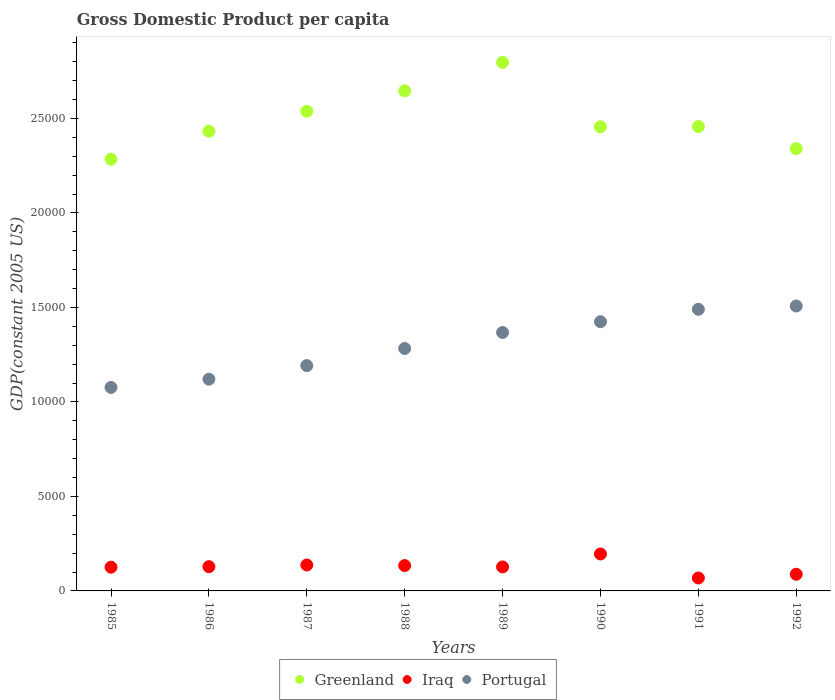How many different coloured dotlines are there?
Keep it short and to the point. 3. What is the GDP per capita in Portugal in 1987?
Offer a very short reply. 1.19e+04. Across all years, what is the maximum GDP per capita in Iraq?
Your response must be concise. 1954.86. Across all years, what is the minimum GDP per capita in Iraq?
Provide a succinct answer. 684.25. In which year was the GDP per capita in Portugal minimum?
Ensure brevity in your answer.  1985. What is the total GDP per capita in Portugal in the graph?
Make the answer very short. 1.05e+05. What is the difference between the GDP per capita in Iraq in 1989 and that in 1992?
Offer a terse response. 388.01. What is the difference between the GDP per capita in Portugal in 1989 and the GDP per capita in Greenland in 1990?
Your response must be concise. -1.09e+04. What is the average GDP per capita in Iraq per year?
Ensure brevity in your answer.  1255.23. In the year 1987, what is the difference between the GDP per capita in Iraq and GDP per capita in Portugal?
Ensure brevity in your answer.  -1.06e+04. What is the ratio of the GDP per capita in Iraq in 1985 to that in 1992?
Make the answer very short. 1.42. What is the difference between the highest and the second highest GDP per capita in Greenland?
Your response must be concise. 1506.96. What is the difference between the highest and the lowest GDP per capita in Portugal?
Your answer should be compact. 4308.08. In how many years, is the GDP per capita in Greenland greater than the average GDP per capita in Greenland taken over all years?
Provide a succinct answer. 3. Does the GDP per capita in Portugal monotonically increase over the years?
Your answer should be compact. Yes. Is the GDP per capita in Greenland strictly greater than the GDP per capita in Iraq over the years?
Give a very brief answer. Yes. Is the GDP per capita in Iraq strictly less than the GDP per capita in Greenland over the years?
Offer a very short reply. Yes. How many dotlines are there?
Your answer should be very brief. 3. Are the values on the major ticks of Y-axis written in scientific E-notation?
Your answer should be very brief. No. Does the graph contain any zero values?
Offer a terse response. No. What is the title of the graph?
Keep it short and to the point. Gross Domestic Product per capita. What is the label or title of the Y-axis?
Your answer should be compact. GDP(constant 2005 US). What is the GDP(constant 2005 US) of Greenland in 1985?
Provide a short and direct response. 2.28e+04. What is the GDP(constant 2005 US) of Iraq in 1985?
Offer a very short reply. 1254.49. What is the GDP(constant 2005 US) in Portugal in 1985?
Ensure brevity in your answer.  1.08e+04. What is the GDP(constant 2005 US) in Greenland in 1986?
Make the answer very short. 2.43e+04. What is the GDP(constant 2005 US) in Iraq in 1986?
Keep it short and to the point. 1283.02. What is the GDP(constant 2005 US) in Portugal in 1986?
Your answer should be compact. 1.12e+04. What is the GDP(constant 2005 US) of Greenland in 1987?
Keep it short and to the point. 2.54e+04. What is the GDP(constant 2005 US) of Iraq in 1987?
Your response must be concise. 1371.78. What is the GDP(constant 2005 US) of Portugal in 1987?
Your response must be concise. 1.19e+04. What is the GDP(constant 2005 US) of Greenland in 1988?
Provide a short and direct response. 2.65e+04. What is the GDP(constant 2005 US) of Iraq in 1988?
Offer a very short reply. 1341.55. What is the GDP(constant 2005 US) of Portugal in 1988?
Provide a succinct answer. 1.28e+04. What is the GDP(constant 2005 US) in Greenland in 1989?
Give a very brief answer. 2.80e+04. What is the GDP(constant 2005 US) of Iraq in 1989?
Make the answer very short. 1269.95. What is the GDP(constant 2005 US) of Portugal in 1989?
Offer a very short reply. 1.37e+04. What is the GDP(constant 2005 US) of Greenland in 1990?
Your answer should be compact. 2.46e+04. What is the GDP(constant 2005 US) in Iraq in 1990?
Give a very brief answer. 1954.86. What is the GDP(constant 2005 US) in Portugal in 1990?
Offer a terse response. 1.42e+04. What is the GDP(constant 2005 US) in Greenland in 1991?
Your answer should be very brief. 2.46e+04. What is the GDP(constant 2005 US) of Iraq in 1991?
Make the answer very short. 684.25. What is the GDP(constant 2005 US) in Portugal in 1991?
Keep it short and to the point. 1.49e+04. What is the GDP(constant 2005 US) of Greenland in 1992?
Provide a short and direct response. 2.34e+04. What is the GDP(constant 2005 US) of Iraq in 1992?
Make the answer very short. 881.94. What is the GDP(constant 2005 US) of Portugal in 1992?
Ensure brevity in your answer.  1.51e+04. Across all years, what is the maximum GDP(constant 2005 US) in Greenland?
Keep it short and to the point. 2.80e+04. Across all years, what is the maximum GDP(constant 2005 US) of Iraq?
Give a very brief answer. 1954.86. Across all years, what is the maximum GDP(constant 2005 US) of Portugal?
Provide a succinct answer. 1.51e+04. Across all years, what is the minimum GDP(constant 2005 US) of Greenland?
Your answer should be compact. 2.28e+04. Across all years, what is the minimum GDP(constant 2005 US) of Iraq?
Offer a terse response. 684.25. Across all years, what is the minimum GDP(constant 2005 US) of Portugal?
Your response must be concise. 1.08e+04. What is the total GDP(constant 2005 US) in Greenland in the graph?
Offer a very short reply. 2.00e+05. What is the total GDP(constant 2005 US) of Iraq in the graph?
Ensure brevity in your answer.  1.00e+04. What is the total GDP(constant 2005 US) of Portugal in the graph?
Your answer should be compact. 1.05e+05. What is the difference between the GDP(constant 2005 US) in Greenland in 1985 and that in 1986?
Make the answer very short. -1483.84. What is the difference between the GDP(constant 2005 US) in Iraq in 1985 and that in 1986?
Your answer should be very brief. -28.53. What is the difference between the GDP(constant 2005 US) of Portugal in 1985 and that in 1986?
Keep it short and to the point. -435.71. What is the difference between the GDP(constant 2005 US) in Greenland in 1985 and that in 1987?
Offer a very short reply. -2540.85. What is the difference between the GDP(constant 2005 US) in Iraq in 1985 and that in 1987?
Your answer should be compact. -117.29. What is the difference between the GDP(constant 2005 US) of Portugal in 1985 and that in 1987?
Provide a succinct answer. -1153.88. What is the difference between the GDP(constant 2005 US) in Greenland in 1985 and that in 1988?
Keep it short and to the point. -3620.71. What is the difference between the GDP(constant 2005 US) in Iraq in 1985 and that in 1988?
Provide a succinct answer. -87.06. What is the difference between the GDP(constant 2005 US) of Portugal in 1985 and that in 1988?
Make the answer very short. -2060.05. What is the difference between the GDP(constant 2005 US) of Greenland in 1985 and that in 1989?
Provide a short and direct response. -5127.67. What is the difference between the GDP(constant 2005 US) in Iraq in 1985 and that in 1989?
Provide a succinct answer. -15.45. What is the difference between the GDP(constant 2005 US) in Portugal in 1985 and that in 1989?
Provide a short and direct response. -2906.2. What is the difference between the GDP(constant 2005 US) in Greenland in 1985 and that in 1990?
Keep it short and to the point. -1716.81. What is the difference between the GDP(constant 2005 US) in Iraq in 1985 and that in 1990?
Your response must be concise. -700.37. What is the difference between the GDP(constant 2005 US) in Portugal in 1985 and that in 1990?
Offer a very short reply. -3477.42. What is the difference between the GDP(constant 2005 US) in Greenland in 1985 and that in 1991?
Make the answer very short. -1733.15. What is the difference between the GDP(constant 2005 US) of Iraq in 1985 and that in 1991?
Offer a terse response. 570.24. What is the difference between the GDP(constant 2005 US) in Portugal in 1985 and that in 1991?
Ensure brevity in your answer.  -4134. What is the difference between the GDP(constant 2005 US) of Greenland in 1985 and that in 1992?
Offer a very short reply. -561.39. What is the difference between the GDP(constant 2005 US) in Iraq in 1985 and that in 1992?
Make the answer very short. 372.55. What is the difference between the GDP(constant 2005 US) in Portugal in 1985 and that in 1992?
Provide a succinct answer. -4308.08. What is the difference between the GDP(constant 2005 US) in Greenland in 1986 and that in 1987?
Make the answer very short. -1057.01. What is the difference between the GDP(constant 2005 US) of Iraq in 1986 and that in 1987?
Offer a terse response. -88.76. What is the difference between the GDP(constant 2005 US) in Portugal in 1986 and that in 1987?
Your response must be concise. -718.17. What is the difference between the GDP(constant 2005 US) of Greenland in 1986 and that in 1988?
Keep it short and to the point. -2136.87. What is the difference between the GDP(constant 2005 US) of Iraq in 1986 and that in 1988?
Give a very brief answer. -58.53. What is the difference between the GDP(constant 2005 US) of Portugal in 1986 and that in 1988?
Make the answer very short. -1624.35. What is the difference between the GDP(constant 2005 US) in Greenland in 1986 and that in 1989?
Offer a very short reply. -3643.83. What is the difference between the GDP(constant 2005 US) of Iraq in 1986 and that in 1989?
Give a very brief answer. 13.07. What is the difference between the GDP(constant 2005 US) in Portugal in 1986 and that in 1989?
Ensure brevity in your answer.  -2470.5. What is the difference between the GDP(constant 2005 US) in Greenland in 1986 and that in 1990?
Make the answer very short. -232.97. What is the difference between the GDP(constant 2005 US) of Iraq in 1986 and that in 1990?
Offer a very short reply. -671.84. What is the difference between the GDP(constant 2005 US) in Portugal in 1986 and that in 1990?
Ensure brevity in your answer.  -3041.72. What is the difference between the GDP(constant 2005 US) of Greenland in 1986 and that in 1991?
Provide a succinct answer. -249.3. What is the difference between the GDP(constant 2005 US) of Iraq in 1986 and that in 1991?
Your answer should be compact. 598.77. What is the difference between the GDP(constant 2005 US) of Portugal in 1986 and that in 1991?
Offer a very short reply. -3698.3. What is the difference between the GDP(constant 2005 US) in Greenland in 1986 and that in 1992?
Ensure brevity in your answer.  922.46. What is the difference between the GDP(constant 2005 US) of Iraq in 1986 and that in 1992?
Offer a terse response. 401.08. What is the difference between the GDP(constant 2005 US) of Portugal in 1986 and that in 1992?
Offer a terse response. -3872.37. What is the difference between the GDP(constant 2005 US) in Greenland in 1987 and that in 1988?
Provide a short and direct response. -1079.85. What is the difference between the GDP(constant 2005 US) of Iraq in 1987 and that in 1988?
Keep it short and to the point. 30.23. What is the difference between the GDP(constant 2005 US) in Portugal in 1987 and that in 1988?
Offer a very short reply. -906.18. What is the difference between the GDP(constant 2005 US) of Greenland in 1987 and that in 1989?
Ensure brevity in your answer.  -2586.82. What is the difference between the GDP(constant 2005 US) of Iraq in 1987 and that in 1989?
Your response must be concise. 101.83. What is the difference between the GDP(constant 2005 US) in Portugal in 1987 and that in 1989?
Your answer should be compact. -1752.33. What is the difference between the GDP(constant 2005 US) of Greenland in 1987 and that in 1990?
Provide a short and direct response. 824.04. What is the difference between the GDP(constant 2005 US) of Iraq in 1987 and that in 1990?
Keep it short and to the point. -583.08. What is the difference between the GDP(constant 2005 US) in Portugal in 1987 and that in 1990?
Your response must be concise. -2323.55. What is the difference between the GDP(constant 2005 US) of Greenland in 1987 and that in 1991?
Your answer should be very brief. 807.71. What is the difference between the GDP(constant 2005 US) of Iraq in 1987 and that in 1991?
Offer a very short reply. 687.53. What is the difference between the GDP(constant 2005 US) of Portugal in 1987 and that in 1991?
Your response must be concise. -2980.13. What is the difference between the GDP(constant 2005 US) of Greenland in 1987 and that in 1992?
Give a very brief answer. 1979.47. What is the difference between the GDP(constant 2005 US) of Iraq in 1987 and that in 1992?
Give a very brief answer. 489.84. What is the difference between the GDP(constant 2005 US) of Portugal in 1987 and that in 1992?
Provide a succinct answer. -3154.2. What is the difference between the GDP(constant 2005 US) in Greenland in 1988 and that in 1989?
Provide a succinct answer. -1506.96. What is the difference between the GDP(constant 2005 US) in Iraq in 1988 and that in 1989?
Your answer should be compact. 71.6. What is the difference between the GDP(constant 2005 US) in Portugal in 1988 and that in 1989?
Offer a very short reply. -846.15. What is the difference between the GDP(constant 2005 US) in Greenland in 1988 and that in 1990?
Give a very brief answer. 1903.89. What is the difference between the GDP(constant 2005 US) in Iraq in 1988 and that in 1990?
Make the answer very short. -613.31. What is the difference between the GDP(constant 2005 US) in Portugal in 1988 and that in 1990?
Offer a terse response. -1417.37. What is the difference between the GDP(constant 2005 US) in Greenland in 1988 and that in 1991?
Provide a succinct answer. 1887.56. What is the difference between the GDP(constant 2005 US) of Iraq in 1988 and that in 1991?
Provide a succinct answer. 657.3. What is the difference between the GDP(constant 2005 US) in Portugal in 1988 and that in 1991?
Ensure brevity in your answer.  -2073.95. What is the difference between the GDP(constant 2005 US) in Greenland in 1988 and that in 1992?
Give a very brief answer. 3059.32. What is the difference between the GDP(constant 2005 US) in Iraq in 1988 and that in 1992?
Keep it short and to the point. 459.61. What is the difference between the GDP(constant 2005 US) of Portugal in 1988 and that in 1992?
Ensure brevity in your answer.  -2248.02. What is the difference between the GDP(constant 2005 US) in Greenland in 1989 and that in 1990?
Keep it short and to the point. 3410.86. What is the difference between the GDP(constant 2005 US) of Iraq in 1989 and that in 1990?
Your answer should be compact. -684.92. What is the difference between the GDP(constant 2005 US) in Portugal in 1989 and that in 1990?
Your answer should be very brief. -571.22. What is the difference between the GDP(constant 2005 US) in Greenland in 1989 and that in 1991?
Make the answer very short. 3394.52. What is the difference between the GDP(constant 2005 US) in Iraq in 1989 and that in 1991?
Offer a very short reply. 585.69. What is the difference between the GDP(constant 2005 US) of Portugal in 1989 and that in 1991?
Offer a terse response. -1227.8. What is the difference between the GDP(constant 2005 US) in Greenland in 1989 and that in 1992?
Keep it short and to the point. 4566.28. What is the difference between the GDP(constant 2005 US) of Iraq in 1989 and that in 1992?
Your response must be concise. 388.01. What is the difference between the GDP(constant 2005 US) of Portugal in 1989 and that in 1992?
Provide a short and direct response. -1401.87. What is the difference between the GDP(constant 2005 US) in Greenland in 1990 and that in 1991?
Give a very brief answer. -16.33. What is the difference between the GDP(constant 2005 US) in Iraq in 1990 and that in 1991?
Make the answer very short. 1270.61. What is the difference between the GDP(constant 2005 US) of Portugal in 1990 and that in 1991?
Your answer should be very brief. -656.58. What is the difference between the GDP(constant 2005 US) in Greenland in 1990 and that in 1992?
Your answer should be very brief. 1155.43. What is the difference between the GDP(constant 2005 US) of Iraq in 1990 and that in 1992?
Keep it short and to the point. 1072.92. What is the difference between the GDP(constant 2005 US) of Portugal in 1990 and that in 1992?
Give a very brief answer. -830.65. What is the difference between the GDP(constant 2005 US) of Greenland in 1991 and that in 1992?
Make the answer very short. 1171.76. What is the difference between the GDP(constant 2005 US) of Iraq in 1991 and that in 1992?
Your answer should be compact. -197.68. What is the difference between the GDP(constant 2005 US) in Portugal in 1991 and that in 1992?
Offer a terse response. -174.07. What is the difference between the GDP(constant 2005 US) of Greenland in 1985 and the GDP(constant 2005 US) of Iraq in 1986?
Your answer should be compact. 2.16e+04. What is the difference between the GDP(constant 2005 US) in Greenland in 1985 and the GDP(constant 2005 US) in Portugal in 1986?
Offer a terse response. 1.16e+04. What is the difference between the GDP(constant 2005 US) in Iraq in 1985 and the GDP(constant 2005 US) in Portugal in 1986?
Make the answer very short. -9949.29. What is the difference between the GDP(constant 2005 US) in Greenland in 1985 and the GDP(constant 2005 US) in Iraq in 1987?
Provide a succinct answer. 2.15e+04. What is the difference between the GDP(constant 2005 US) in Greenland in 1985 and the GDP(constant 2005 US) in Portugal in 1987?
Ensure brevity in your answer.  1.09e+04. What is the difference between the GDP(constant 2005 US) of Iraq in 1985 and the GDP(constant 2005 US) of Portugal in 1987?
Offer a very short reply. -1.07e+04. What is the difference between the GDP(constant 2005 US) of Greenland in 1985 and the GDP(constant 2005 US) of Iraq in 1988?
Provide a succinct answer. 2.15e+04. What is the difference between the GDP(constant 2005 US) of Greenland in 1985 and the GDP(constant 2005 US) of Portugal in 1988?
Offer a terse response. 1.00e+04. What is the difference between the GDP(constant 2005 US) in Iraq in 1985 and the GDP(constant 2005 US) in Portugal in 1988?
Ensure brevity in your answer.  -1.16e+04. What is the difference between the GDP(constant 2005 US) in Greenland in 1985 and the GDP(constant 2005 US) in Iraq in 1989?
Keep it short and to the point. 2.16e+04. What is the difference between the GDP(constant 2005 US) of Greenland in 1985 and the GDP(constant 2005 US) of Portugal in 1989?
Provide a short and direct response. 9165.37. What is the difference between the GDP(constant 2005 US) in Iraq in 1985 and the GDP(constant 2005 US) in Portugal in 1989?
Provide a short and direct response. -1.24e+04. What is the difference between the GDP(constant 2005 US) in Greenland in 1985 and the GDP(constant 2005 US) in Iraq in 1990?
Your answer should be very brief. 2.09e+04. What is the difference between the GDP(constant 2005 US) in Greenland in 1985 and the GDP(constant 2005 US) in Portugal in 1990?
Keep it short and to the point. 8594.15. What is the difference between the GDP(constant 2005 US) of Iraq in 1985 and the GDP(constant 2005 US) of Portugal in 1990?
Your answer should be compact. -1.30e+04. What is the difference between the GDP(constant 2005 US) in Greenland in 1985 and the GDP(constant 2005 US) in Iraq in 1991?
Make the answer very short. 2.22e+04. What is the difference between the GDP(constant 2005 US) in Greenland in 1985 and the GDP(constant 2005 US) in Portugal in 1991?
Your response must be concise. 7937.57. What is the difference between the GDP(constant 2005 US) of Iraq in 1985 and the GDP(constant 2005 US) of Portugal in 1991?
Keep it short and to the point. -1.36e+04. What is the difference between the GDP(constant 2005 US) of Greenland in 1985 and the GDP(constant 2005 US) of Iraq in 1992?
Offer a very short reply. 2.20e+04. What is the difference between the GDP(constant 2005 US) of Greenland in 1985 and the GDP(constant 2005 US) of Portugal in 1992?
Make the answer very short. 7763.5. What is the difference between the GDP(constant 2005 US) of Iraq in 1985 and the GDP(constant 2005 US) of Portugal in 1992?
Make the answer very short. -1.38e+04. What is the difference between the GDP(constant 2005 US) of Greenland in 1986 and the GDP(constant 2005 US) of Iraq in 1987?
Your response must be concise. 2.30e+04. What is the difference between the GDP(constant 2005 US) in Greenland in 1986 and the GDP(constant 2005 US) in Portugal in 1987?
Offer a very short reply. 1.24e+04. What is the difference between the GDP(constant 2005 US) of Iraq in 1986 and the GDP(constant 2005 US) of Portugal in 1987?
Provide a short and direct response. -1.06e+04. What is the difference between the GDP(constant 2005 US) of Greenland in 1986 and the GDP(constant 2005 US) of Iraq in 1988?
Provide a short and direct response. 2.30e+04. What is the difference between the GDP(constant 2005 US) of Greenland in 1986 and the GDP(constant 2005 US) of Portugal in 1988?
Offer a terse response. 1.15e+04. What is the difference between the GDP(constant 2005 US) of Iraq in 1986 and the GDP(constant 2005 US) of Portugal in 1988?
Your response must be concise. -1.15e+04. What is the difference between the GDP(constant 2005 US) in Greenland in 1986 and the GDP(constant 2005 US) in Iraq in 1989?
Give a very brief answer. 2.31e+04. What is the difference between the GDP(constant 2005 US) of Greenland in 1986 and the GDP(constant 2005 US) of Portugal in 1989?
Your answer should be compact. 1.06e+04. What is the difference between the GDP(constant 2005 US) of Iraq in 1986 and the GDP(constant 2005 US) of Portugal in 1989?
Your answer should be very brief. -1.24e+04. What is the difference between the GDP(constant 2005 US) of Greenland in 1986 and the GDP(constant 2005 US) of Iraq in 1990?
Offer a terse response. 2.24e+04. What is the difference between the GDP(constant 2005 US) of Greenland in 1986 and the GDP(constant 2005 US) of Portugal in 1990?
Give a very brief answer. 1.01e+04. What is the difference between the GDP(constant 2005 US) of Iraq in 1986 and the GDP(constant 2005 US) of Portugal in 1990?
Make the answer very short. -1.30e+04. What is the difference between the GDP(constant 2005 US) in Greenland in 1986 and the GDP(constant 2005 US) in Iraq in 1991?
Make the answer very short. 2.36e+04. What is the difference between the GDP(constant 2005 US) of Greenland in 1986 and the GDP(constant 2005 US) of Portugal in 1991?
Make the answer very short. 9421.42. What is the difference between the GDP(constant 2005 US) of Iraq in 1986 and the GDP(constant 2005 US) of Portugal in 1991?
Your response must be concise. -1.36e+04. What is the difference between the GDP(constant 2005 US) in Greenland in 1986 and the GDP(constant 2005 US) in Iraq in 1992?
Offer a very short reply. 2.34e+04. What is the difference between the GDP(constant 2005 US) of Greenland in 1986 and the GDP(constant 2005 US) of Portugal in 1992?
Offer a terse response. 9247.34. What is the difference between the GDP(constant 2005 US) in Iraq in 1986 and the GDP(constant 2005 US) in Portugal in 1992?
Provide a succinct answer. -1.38e+04. What is the difference between the GDP(constant 2005 US) in Greenland in 1987 and the GDP(constant 2005 US) in Iraq in 1988?
Ensure brevity in your answer.  2.40e+04. What is the difference between the GDP(constant 2005 US) of Greenland in 1987 and the GDP(constant 2005 US) of Portugal in 1988?
Ensure brevity in your answer.  1.26e+04. What is the difference between the GDP(constant 2005 US) in Iraq in 1987 and the GDP(constant 2005 US) in Portugal in 1988?
Make the answer very short. -1.15e+04. What is the difference between the GDP(constant 2005 US) of Greenland in 1987 and the GDP(constant 2005 US) of Iraq in 1989?
Give a very brief answer. 2.41e+04. What is the difference between the GDP(constant 2005 US) in Greenland in 1987 and the GDP(constant 2005 US) in Portugal in 1989?
Your answer should be compact. 1.17e+04. What is the difference between the GDP(constant 2005 US) of Iraq in 1987 and the GDP(constant 2005 US) of Portugal in 1989?
Ensure brevity in your answer.  -1.23e+04. What is the difference between the GDP(constant 2005 US) of Greenland in 1987 and the GDP(constant 2005 US) of Iraq in 1990?
Your answer should be very brief. 2.34e+04. What is the difference between the GDP(constant 2005 US) in Greenland in 1987 and the GDP(constant 2005 US) in Portugal in 1990?
Keep it short and to the point. 1.11e+04. What is the difference between the GDP(constant 2005 US) of Iraq in 1987 and the GDP(constant 2005 US) of Portugal in 1990?
Your answer should be compact. -1.29e+04. What is the difference between the GDP(constant 2005 US) in Greenland in 1987 and the GDP(constant 2005 US) in Iraq in 1991?
Offer a very short reply. 2.47e+04. What is the difference between the GDP(constant 2005 US) in Greenland in 1987 and the GDP(constant 2005 US) in Portugal in 1991?
Provide a succinct answer. 1.05e+04. What is the difference between the GDP(constant 2005 US) of Iraq in 1987 and the GDP(constant 2005 US) of Portugal in 1991?
Your answer should be compact. -1.35e+04. What is the difference between the GDP(constant 2005 US) in Greenland in 1987 and the GDP(constant 2005 US) in Iraq in 1992?
Your answer should be compact. 2.45e+04. What is the difference between the GDP(constant 2005 US) in Greenland in 1987 and the GDP(constant 2005 US) in Portugal in 1992?
Your answer should be very brief. 1.03e+04. What is the difference between the GDP(constant 2005 US) of Iraq in 1987 and the GDP(constant 2005 US) of Portugal in 1992?
Make the answer very short. -1.37e+04. What is the difference between the GDP(constant 2005 US) of Greenland in 1988 and the GDP(constant 2005 US) of Iraq in 1989?
Provide a succinct answer. 2.52e+04. What is the difference between the GDP(constant 2005 US) of Greenland in 1988 and the GDP(constant 2005 US) of Portugal in 1989?
Your response must be concise. 1.28e+04. What is the difference between the GDP(constant 2005 US) of Iraq in 1988 and the GDP(constant 2005 US) of Portugal in 1989?
Your answer should be very brief. -1.23e+04. What is the difference between the GDP(constant 2005 US) of Greenland in 1988 and the GDP(constant 2005 US) of Iraq in 1990?
Offer a very short reply. 2.45e+04. What is the difference between the GDP(constant 2005 US) in Greenland in 1988 and the GDP(constant 2005 US) in Portugal in 1990?
Your answer should be compact. 1.22e+04. What is the difference between the GDP(constant 2005 US) in Iraq in 1988 and the GDP(constant 2005 US) in Portugal in 1990?
Your answer should be very brief. -1.29e+04. What is the difference between the GDP(constant 2005 US) of Greenland in 1988 and the GDP(constant 2005 US) of Iraq in 1991?
Offer a very short reply. 2.58e+04. What is the difference between the GDP(constant 2005 US) in Greenland in 1988 and the GDP(constant 2005 US) in Portugal in 1991?
Provide a short and direct response. 1.16e+04. What is the difference between the GDP(constant 2005 US) of Iraq in 1988 and the GDP(constant 2005 US) of Portugal in 1991?
Offer a very short reply. -1.36e+04. What is the difference between the GDP(constant 2005 US) of Greenland in 1988 and the GDP(constant 2005 US) of Iraq in 1992?
Ensure brevity in your answer.  2.56e+04. What is the difference between the GDP(constant 2005 US) of Greenland in 1988 and the GDP(constant 2005 US) of Portugal in 1992?
Ensure brevity in your answer.  1.14e+04. What is the difference between the GDP(constant 2005 US) of Iraq in 1988 and the GDP(constant 2005 US) of Portugal in 1992?
Your answer should be very brief. -1.37e+04. What is the difference between the GDP(constant 2005 US) of Greenland in 1989 and the GDP(constant 2005 US) of Iraq in 1990?
Your answer should be compact. 2.60e+04. What is the difference between the GDP(constant 2005 US) in Greenland in 1989 and the GDP(constant 2005 US) in Portugal in 1990?
Your response must be concise. 1.37e+04. What is the difference between the GDP(constant 2005 US) in Iraq in 1989 and the GDP(constant 2005 US) in Portugal in 1990?
Provide a succinct answer. -1.30e+04. What is the difference between the GDP(constant 2005 US) of Greenland in 1989 and the GDP(constant 2005 US) of Iraq in 1991?
Provide a succinct answer. 2.73e+04. What is the difference between the GDP(constant 2005 US) of Greenland in 1989 and the GDP(constant 2005 US) of Portugal in 1991?
Keep it short and to the point. 1.31e+04. What is the difference between the GDP(constant 2005 US) in Iraq in 1989 and the GDP(constant 2005 US) in Portugal in 1991?
Your answer should be compact. -1.36e+04. What is the difference between the GDP(constant 2005 US) of Greenland in 1989 and the GDP(constant 2005 US) of Iraq in 1992?
Your response must be concise. 2.71e+04. What is the difference between the GDP(constant 2005 US) of Greenland in 1989 and the GDP(constant 2005 US) of Portugal in 1992?
Offer a very short reply. 1.29e+04. What is the difference between the GDP(constant 2005 US) of Iraq in 1989 and the GDP(constant 2005 US) of Portugal in 1992?
Your answer should be compact. -1.38e+04. What is the difference between the GDP(constant 2005 US) of Greenland in 1990 and the GDP(constant 2005 US) of Iraq in 1991?
Provide a short and direct response. 2.39e+04. What is the difference between the GDP(constant 2005 US) of Greenland in 1990 and the GDP(constant 2005 US) of Portugal in 1991?
Provide a succinct answer. 9654.39. What is the difference between the GDP(constant 2005 US) in Iraq in 1990 and the GDP(constant 2005 US) in Portugal in 1991?
Provide a succinct answer. -1.29e+04. What is the difference between the GDP(constant 2005 US) in Greenland in 1990 and the GDP(constant 2005 US) in Iraq in 1992?
Provide a short and direct response. 2.37e+04. What is the difference between the GDP(constant 2005 US) of Greenland in 1990 and the GDP(constant 2005 US) of Portugal in 1992?
Provide a short and direct response. 9480.32. What is the difference between the GDP(constant 2005 US) in Iraq in 1990 and the GDP(constant 2005 US) in Portugal in 1992?
Your answer should be compact. -1.31e+04. What is the difference between the GDP(constant 2005 US) of Greenland in 1991 and the GDP(constant 2005 US) of Iraq in 1992?
Provide a short and direct response. 2.37e+04. What is the difference between the GDP(constant 2005 US) in Greenland in 1991 and the GDP(constant 2005 US) in Portugal in 1992?
Provide a short and direct response. 9496.65. What is the difference between the GDP(constant 2005 US) in Iraq in 1991 and the GDP(constant 2005 US) in Portugal in 1992?
Provide a short and direct response. -1.44e+04. What is the average GDP(constant 2005 US) in Greenland per year?
Provide a short and direct response. 2.49e+04. What is the average GDP(constant 2005 US) in Iraq per year?
Give a very brief answer. 1255.23. What is the average GDP(constant 2005 US) in Portugal per year?
Your answer should be compact. 1.31e+04. In the year 1985, what is the difference between the GDP(constant 2005 US) in Greenland and GDP(constant 2005 US) in Iraq?
Provide a succinct answer. 2.16e+04. In the year 1985, what is the difference between the GDP(constant 2005 US) in Greenland and GDP(constant 2005 US) in Portugal?
Provide a short and direct response. 1.21e+04. In the year 1985, what is the difference between the GDP(constant 2005 US) of Iraq and GDP(constant 2005 US) of Portugal?
Offer a terse response. -9513.59. In the year 1986, what is the difference between the GDP(constant 2005 US) in Greenland and GDP(constant 2005 US) in Iraq?
Ensure brevity in your answer.  2.30e+04. In the year 1986, what is the difference between the GDP(constant 2005 US) in Greenland and GDP(constant 2005 US) in Portugal?
Keep it short and to the point. 1.31e+04. In the year 1986, what is the difference between the GDP(constant 2005 US) in Iraq and GDP(constant 2005 US) in Portugal?
Make the answer very short. -9920.76. In the year 1987, what is the difference between the GDP(constant 2005 US) of Greenland and GDP(constant 2005 US) of Iraq?
Provide a short and direct response. 2.40e+04. In the year 1987, what is the difference between the GDP(constant 2005 US) in Greenland and GDP(constant 2005 US) in Portugal?
Provide a short and direct response. 1.35e+04. In the year 1987, what is the difference between the GDP(constant 2005 US) of Iraq and GDP(constant 2005 US) of Portugal?
Your answer should be very brief. -1.06e+04. In the year 1988, what is the difference between the GDP(constant 2005 US) in Greenland and GDP(constant 2005 US) in Iraq?
Your response must be concise. 2.51e+04. In the year 1988, what is the difference between the GDP(constant 2005 US) of Greenland and GDP(constant 2005 US) of Portugal?
Give a very brief answer. 1.36e+04. In the year 1988, what is the difference between the GDP(constant 2005 US) of Iraq and GDP(constant 2005 US) of Portugal?
Keep it short and to the point. -1.15e+04. In the year 1989, what is the difference between the GDP(constant 2005 US) in Greenland and GDP(constant 2005 US) in Iraq?
Ensure brevity in your answer.  2.67e+04. In the year 1989, what is the difference between the GDP(constant 2005 US) of Greenland and GDP(constant 2005 US) of Portugal?
Provide a short and direct response. 1.43e+04. In the year 1989, what is the difference between the GDP(constant 2005 US) of Iraq and GDP(constant 2005 US) of Portugal?
Keep it short and to the point. -1.24e+04. In the year 1990, what is the difference between the GDP(constant 2005 US) of Greenland and GDP(constant 2005 US) of Iraq?
Give a very brief answer. 2.26e+04. In the year 1990, what is the difference between the GDP(constant 2005 US) of Greenland and GDP(constant 2005 US) of Portugal?
Your response must be concise. 1.03e+04. In the year 1990, what is the difference between the GDP(constant 2005 US) in Iraq and GDP(constant 2005 US) in Portugal?
Your answer should be very brief. -1.23e+04. In the year 1991, what is the difference between the GDP(constant 2005 US) in Greenland and GDP(constant 2005 US) in Iraq?
Your answer should be very brief. 2.39e+04. In the year 1991, what is the difference between the GDP(constant 2005 US) in Greenland and GDP(constant 2005 US) in Portugal?
Make the answer very short. 9670.72. In the year 1991, what is the difference between the GDP(constant 2005 US) of Iraq and GDP(constant 2005 US) of Portugal?
Ensure brevity in your answer.  -1.42e+04. In the year 1992, what is the difference between the GDP(constant 2005 US) in Greenland and GDP(constant 2005 US) in Iraq?
Give a very brief answer. 2.25e+04. In the year 1992, what is the difference between the GDP(constant 2005 US) in Greenland and GDP(constant 2005 US) in Portugal?
Make the answer very short. 8324.89. In the year 1992, what is the difference between the GDP(constant 2005 US) in Iraq and GDP(constant 2005 US) in Portugal?
Offer a very short reply. -1.42e+04. What is the ratio of the GDP(constant 2005 US) of Greenland in 1985 to that in 1986?
Give a very brief answer. 0.94. What is the ratio of the GDP(constant 2005 US) of Iraq in 1985 to that in 1986?
Offer a terse response. 0.98. What is the ratio of the GDP(constant 2005 US) of Portugal in 1985 to that in 1986?
Give a very brief answer. 0.96. What is the ratio of the GDP(constant 2005 US) in Greenland in 1985 to that in 1987?
Give a very brief answer. 0.9. What is the ratio of the GDP(constant 2005 US) in Iraq in 1985 to that in 1987?
Keep it short and to the point. 0.91. What is the ratio of the GDP(constant 2005 US) of Portugal in 1985 to that in 1987?
Your answer should be compact. 0.9. What is the ratio of the GDP(constant 2005 US) of Greenland in 1985 to that in 1988?
Offer a terse response. 0.86. What is the ratio of the GDP(constant 2005 US) of Iraq in 1985 to that in 1988?
Ensure brevity in your answer.  0.94. What is the ratio of the GDP(constant 2005 US) of Portugal in 1985 to that in 1988?
Your answer should be compact. 0.84. What is the ratio of the GDP(constant 2005 US) of Greenland in 1985 to that in 1989?
Offer a terse response. 0.82. What is the ratio of the GDP(constant 2005 US) of Iraq in 1985 to that in 1989?
Your answer should be compact. 0.99. What is the ratio of the GDP(constant 2005 US) of Portugal in 1985 to that in 1989?
Offer a terse response. 0.79. What is the ratio of the GDP(constant 2005 US) in Greenland in 1985 to that in 1990?
Give a very brief answer. 0.93. What is the ratio of the GDP(constant 2005 US) of Iraq in 1985 to that in 1990?
Give a very brief answer. 0.64. What is the ratio of the GDP(constant 2005 US) in Portugal in 1985 to that in 1990?
Your response must be concise. 0.76. What is the ratio of the GDP(constant 2005 US) in Greenland in 1985 to that in 1991?
Offer a very short reply. 0.93. What is the ratio of the GDP(constant 2005 US) in Iraq in 1985 to that in 1991?
Make the answer very short. 1.83. What is the ratio of the GDP(constant 2005 US) in Portugal in 1985 to that in 1991?
Provide a succinct answer. 0.72. What is the ratio of the GDP(constant 2005 US) in Iraq in 1985 to that in 1992?
Offer a terse response. 1.42. What is the ratio of the GDP(constant 2005 US) of Portugal in 1985 to that in 1992?
Offer a very short reply. 0.71. What is the ratio of the GDP(constant 2005 US) of Greenland in 1986 to that in 1987?
Ensure brevity in your answer.  0.96. What is the ratio of the GDP(constant 2005 US) in Iraq in 1986 to that in 1987?
Make the answer very short. 0.94. What is the ratio of the GDP(constant 2005 US) of Portugal in 1986 to that in 1987?
Provide a succinct answer. 0.94. What is the ratio of the GDP(constant 2005 US) of Greenland in 1986 to that in 1988?
Your answer should be compact. 0.92. What is the ratio of the GDP(constant 2005 US) in Iraq in 1986 to that in 1988?
Make the answer very short. 0.96. What is the ratio of the GDP(constant 2005 US) in Portugal in 1986 to that in 1988?
Your response must be concise. 0.87. What is the ratio of the GDP(constant 2005 US) in Greenland in 1986 to that in 1989?
Provide a succinct answer. 0.87. What is the ratio of the GDP(constant 2005 US) in Iraq in 1986 to that in 1989?
Provide a succinct answer. 1.01. What is the ratio of the GDP(constant 2005 US) of Portugal in 1986 to that in 1989?
Make the answer very short. 0.82. What is the ratio of the GDP(constant 2005 US) in Iraq in 1986 to that in 1990?
Offer a terse response. 0.66. What is the ratio of the GDP(constant 2005 US) of Portugal in 1986 to that in 1990?
Offer a terse response. 0.79. What is the ratio of the GDP(constant 2005 US) in Iraq in 1986 to that in 1991?
Offer a very short reply. 1.88. What is the ratio of the GDP(constant 2005 US) in Portugal in 1986 to that in 1991?
Your answer should be compact. 0.75. What is the ratio of the GDP(constant 2005 US) in Greenland in 1986 to that in 1992?
Offer a very short reply. 1.04. What is the ratio of the GDP(constant 2005 US) of Iraq in 1986 to that in 1992?
Provide a succinct answer. 1.45. What is the ratio of the GDP(constant 2005 US) in Portugal in 1986 to that in 1992?
Provide a short and direct response. 0.74. What is the ratio of the GDP(constant 2005 US) in Greenland in 1987 to that in 1988?
Provide a succinct answer. 0.96. What is the ratio of the GDP(constant 2005 US) in Iraq in 1987 to that in 1988?
Give a very brief answer. 1.02. What is the ratio of the GDP(constant 2005 US) in Portugal in 1987 to that in 1988?
Offer a very short reply. 0.93. What is the ratio of the GDP(constant 2005 US) of Greenland in 1987 to that in 1989?
Provide a short and direct response. 0.91. What is the ratio of the GDP(constant 2005 US) of Iraq in 1987 to that in 1989?
Offer a very short reply. 1.08. What is the ratio of the GDP(constant 2005 US) in Portugal in 1987 to that in 1989?
Keep it short and to the point. 0.87. What is the ratio of the GDP(constant 2005 US) of Greenland in 1987 to that in 1990?
Offer a very short reply. 1.03. What is the ratio of the GDP(constant 2005 US) in Iraq in 1987 to that in 1990?
Your answer should be very brief. 0.7. What is the ratio of the GDP(constant 2005 US) of Portugal in 1987 to that in 1990?
Your response must be concise. 0.84. What is the ratio of the GDP(constant 2005 US) of Greenland in 1987 to that in 1991?
Provide a short and direct response. 1.03. What is the ratio of the GDP(constant 2005 US) in Iraq in 1987 to that in 1991?
Keep it short and to the point. 2. What is the ratio of the GDP(constant 2005 US) in Portugal in 1987 to that in 1991?
Your answer should be very brief. 0.8. What is the ratio of the GDP(constant 2005 US) in Greenland in 1987 to that in 1992?
Provide a succinct answer. 1.08. What is the ratio of the GDP(constant 2005 US) in Iraq in 1987 to that in 1992?
Offer a terse response. 1.56. What is the ratio of the GDP(constant 2005 US) in Portugal in 1987 to that in 1992?
Keep it short and to the point. 0.79. What is the ratio of the GDP(constant 2005 US) in Greenland in 1988 to that in 1989?
Make the answer very short. 0.95. What is the ratio of the GDP(constant 2005 US) of Iraq in 1988 to that in 1989?
Provide a short and direct response. 1.06. What is the ratio of the GDP(constant 2005 US) in Portugal in 1988 to that in 1989?
Provide a succinct answer. 0.94. What is the ratio of the GDP(constant 2005 US) of Greenland in 1988 to that in 1990?
Give a very brief answer. 1.08. What is the ratio of the GDP(constant 2005 US) in Iraq in 1988 to that in 1990?
Ensure brevity in your answer.  0.69. What is the ratio of the GDP(constant 2005 US) of Portugal in 1988 to that in 1990?
Keep it short and to the point. 0.9. What is the ratio of the GDP(constant 2005 US) of Greenland in 1988 to that in 1991?
Your response must be concise. 1.08. What is the ratio of the GDP(constant 2005 US) of Iraq in 1988 to that in 1991?
Keep it short and to the point. 1.96. What is the ratio of the GDP(constant 2005 US) in Portugal in 1988 to that in 1991?
Your response must be concise. 0.86. What is the ratio of the GDP(constant 2005 US) of Greenland in 1988 to that in 1992?
Provide a succinct answer. 1.13. What is the ratio of the GDP(constant 2005 US) of Iraq in 1988 to that in 1992?
Make the answer very short. 1.52. What is the ratio of the GDP(constant 2005 US) of Portugal in 1988 to that in 1992?
Make the answer very short. 0.85. What is the ratio of the GDP(constant 2005 US) of Greenland in 1989 to that in 1990?
Offer a terse response. 1.14. What is the ratio of the GDP(constant 2005 US) of Iraq in 1989 to that in 1990?
Provide a succinct answer. 0.65. What is the ratio of the GDP(constant 2005 US) of Portugal in 1989 to that in 1990?
Offer a very short reply. 0.96. What is the ratio of the GDP(constant 2005 US) of Greenland in 1989 to that in 1991?
Provide a short and direct response. 1.14. What is the ratio of the GDP(constant 2005 US) in Iraq in 1989 to that in 1991?
Offer a terse response. 1.86. What is the ratio of the GDP(constant 2005 US) in Portugal in 1989 to that in 1991?
Make the answer very short. 0.92. What is the ratio of the GDP(constant 2005 US) of Greenland in 1989 to that in 1992?
Offer a very short reply. 1.2. What is the ratio of the GDP(constant 2005 US) in Iraq in 1989 to that in 1992?
Ensure brevity in your answer.  1.44. What is the ratio of the GDP(constant 2005 US) in Portugal in 1989 to that in 1992?
Your response must be concise. 0.91. What is the ratio of the GDP(constant 2005 US) of Iraq in 1990 to that in 1991?
Make the answer very short. 2.86. What is the ratio of the GDP(constant 2005 US) of Portugal in 1990 to that in 1991?
Provide a succinct answer. 0.96. What is the ratio of the GDP(constant 2005 US) in Greenland in 1990 to that in 1992?
Give a very brief answer. 1.05. What is the ratio of the GDP(constant 2005 US) of Iraq in 1990 to that in 1992?
Provide a short and direct response. 2.22. What is the ratio of the GDP(constant 2005 US) in Portugal in 1990 to that in 1992?
Provide a short and direct response. 0.94. What is the ratio of the GDP(constant 2005 US) of Greenland in 1991 to that in 1992?
Your answer should be compact. 1.05. What is the ratio of the GDP(constant 2005 US) of Iraq in 1991 to that in 1992?
Provide a succinct answer. 0.78. What is the ratio of the GDP(constant 2005 US) in Portugal in 1991 to that in 1992?
Provide a short and direct response. 0.99. What is the difference between the highest and the second highest GDP(constant 2005 US) in Greenland?
Keep it short and to the point. 1506.96. What is the difference between the highest and the second highest GDP(constant 2005 US) in Iraq?
Provide a short and direct response. 583.08. What is the difference between the highest and the second highest GDP(constant 2005 US) in Portugal?
Offer a very short reply. 174.07. What is the difference between the highest and the lowest GDP(constant 2005 US) in Greenland?
Make the answer very short. 5127.67. What is the difference between the highest and the lowest GDP(constant 2005 US) in Iraq?
Provide a succinct answer. 1270.61. What is the difference between the highest and the lowest GDP(constant 2005 US) in Portugal?
Provide a succinct answer. 4308.08. 